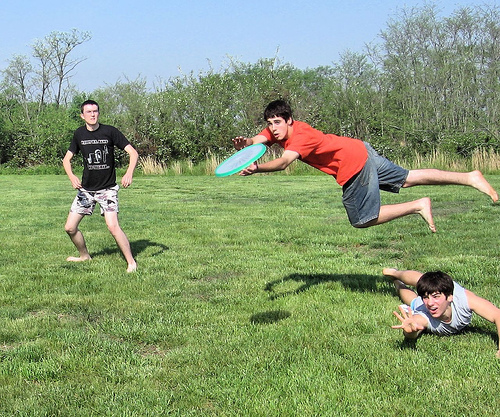Please provide a short description for this region: [0.4, 0.73, 0.5, 0.81]. A patch of short green and yellow grass. 